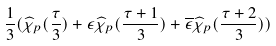<formula> <loc_0><loc_0><loc_500><loc_500>\frac { 1 } { 3 } ( \widehat { \chi } _ { p } ( \frac { \tau } { 3 } ) + \epsilon \widehat { \chi } _ { p } ( \frac { \tau + 1 } { 3 } ) + \overline { \epsilon } \widehat { \chi } _ { p } ( \frac { \tau + 2 } { 3 } ) )</formula> 